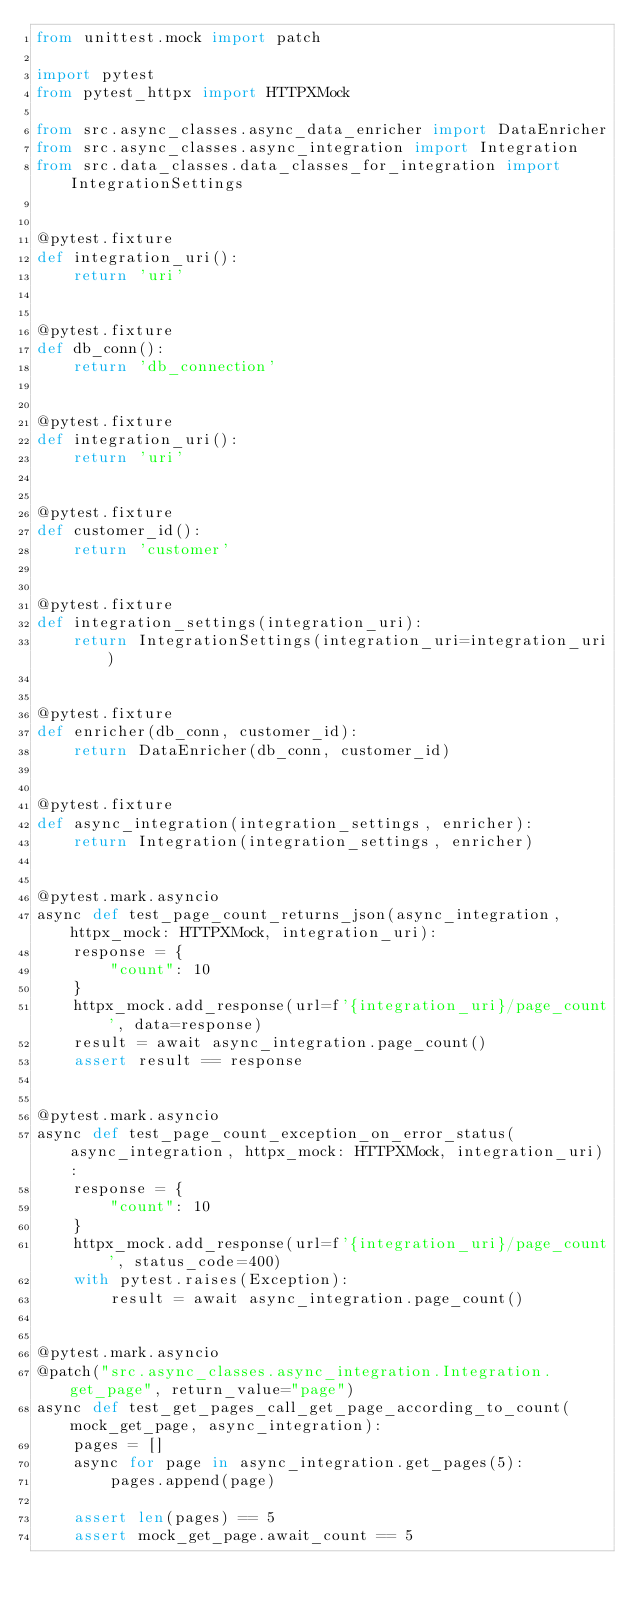Convert code to text. <code><loc_0><loc_0><loc_500><loc_500><_Python_>from unittest.mock import patch

import pytest
from pytest_httpx import HTTPXMock

from src.async_classes.async_data_enricher import DataEnricher
from src.async_classes.async_integration import Integration
from src.data_classes.data_classes_for_integration import IntegrationSettings


@pytest.fixture
def integration_uri():
    return 'uri'


@pytest.fixture
def db_conn():
    return 'db_connection'


@pytest.fixture
def integration_uri():
    return 'uri'


@pytest.fixture
def customer_id():
    return 'customer'


@pytest.fixture
def integration_settings(integration_uri):
    return IntegrationSettings(integration_uri=integration_uri)


@pytest.fixture
def enricher(db_conn, customer_id):
    return DataEnricher(db_conn, customer_id)


@pytest.fixture
def async_integration(integration_settings, enricher):
    return Integration(integration_settings, enricher)


@pytest.mark.asyncio
async def test_page_count_returns_json(async_integration, httpx_mock: HTTPXMock, integration_uri):
    response = {
        "count": 10
    }
    httpx_mock.add_response(url=f'{integration_uri}/page_count', data=response)
    result = await async_integration.page_count()
    assert result == response


@pytest.mark.asyncio
async def test_page_count_exception_on_error_status(async_integration, httpx_mock: HTTPXMock, integration_uri):
    response = {
        "count": 10
    }
    httpx_mock.add_response(url=f'{integration_uri}/page_count', status_code=400)
    with pytest.raises(Exception):
        result = await async_integration.page_count()


@pytest.mark.asyncio
@patch("src.async_classes.async_integration.Integration.get_page", return_value="page")
async def test_get_pages_call_get_page_according_to_count(mock_get_page, async_integration):
    pages = []
    async for page in async_integration.get_pages(5):
        pages.append(page)

    assert len(pages) == 5
    assert mock_get_page.await_count == 5
</code> 